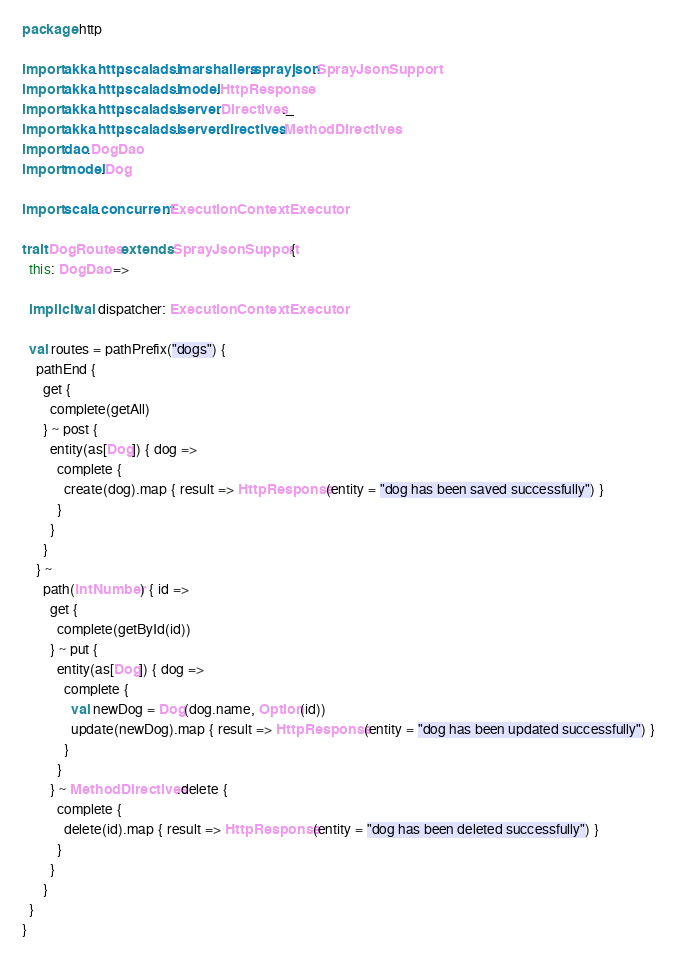<code> <loc_0><loc_0><loc_500><loc_500><_Scala_>package http

import akka.http.scaladsl.marshallers.sprayjson.SprayJsonSupport
import akka.http.scaladsl.model.HttpResponse
import akka.http.scaladsl.server.Directives._
import akka.http.scaladsl.server.directives.MethodDirectives
import dao.DogDao
import model.Dog

import scala.concurrent.ExecutionContextExecutor

trait DogRoutes extends SprayJsonSupport {
  this: DogDao =>

  implicit val dispatcher: ExecutionContextExecutor

  val routes = pathPrefix("dogs") {
    pathEnd {
      get {
        complete(getAll)
      } ~ post {
        entity(as[Dog]) { dog =>
          complete {
            create(dog).map { result => HttpResponse(entity = "dog has been saved successfully") }
          }
        }
      }
    } ~
      path(IntNumber) { id =>
        get {
          complete(getById(id))
        } ~ put {
          entity(as[Dog]) { dog =>
            complete {
              val newDog = Dog(dog.name, Option(id))
              update(newDog).map { result => HttpResponse(entity = "dog has been updated successfully") }
            }
          }
        } ~ MethodDirectives.delete {
          complete {
            delete(id).map { result => HttpResponse(entity = "dog has been deleted successfully") }
          }
        }
      }
  }
}</code> 